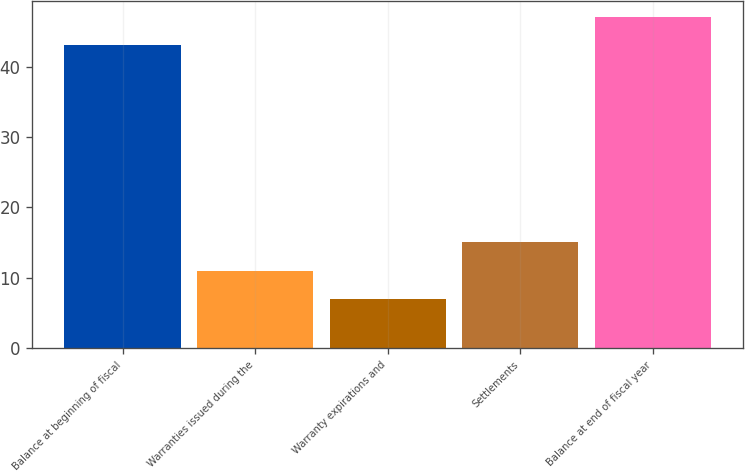<chart> <loc_0><loc_0><loc_500><loc_500><bar_chart><fcel>Balance at beginning of fiscal<fcel>Warranties issued during the<fcel>Warranty expirations and<fcel>Settlements<fcel>Balance at end of fiscal year<nl><fcel>43<fcel>11<fcel>7<fcel>15<fcel>47<nl></chart> 